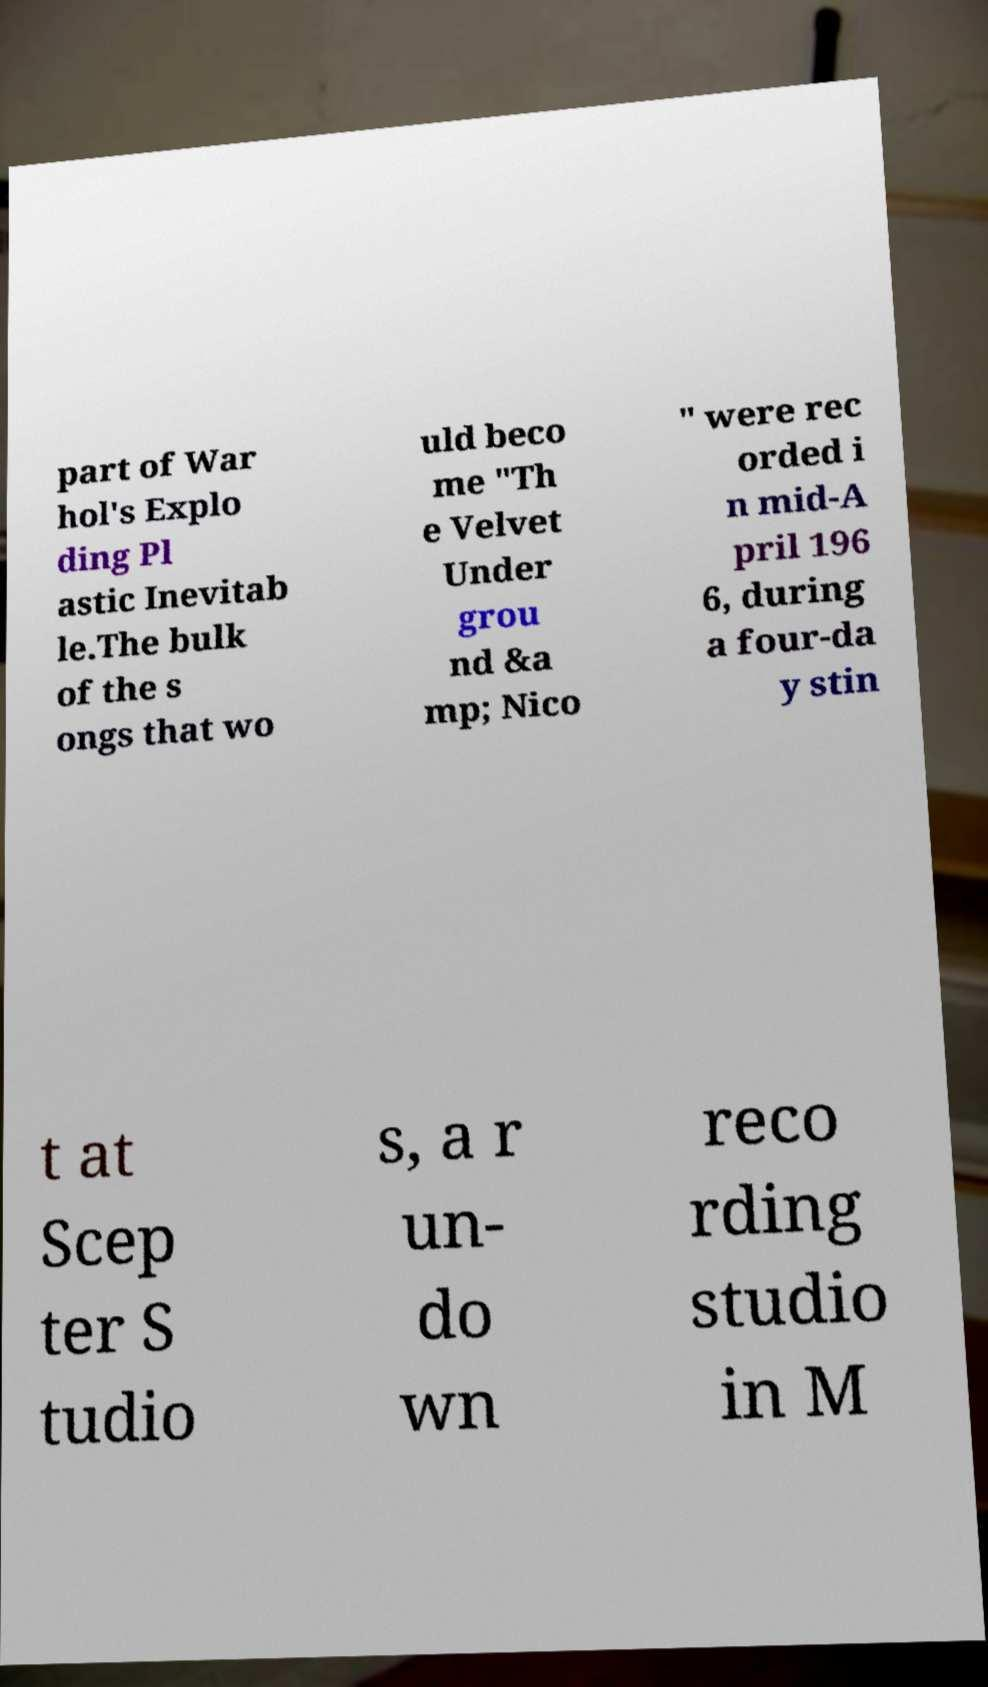Please identify and transcribe the text found in this image. part of War hol's Explo ding Pl astic Inevitab le.The bulk of the s ongs that wo uld beco me "Th e Velvet Under grou nd &a mp; Nico " were rec orded i n mid-A pril 196 6, during a four-da y stin t at Scep ter S tudio s, a r un- do wn reco rding studio in M 